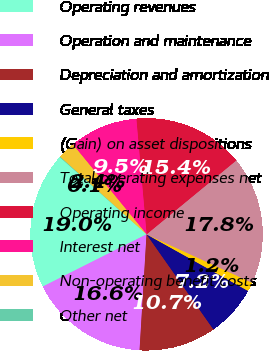Convert chart to OTSL. <chart><loc_0><loc_0><loc_500><loc_500><pie_chart><fcel>Operating revenues<fcel>Operation and maintenance<fcel>Depreciation and amortization<fcel>General taxes<fcel>(Gain) on asset dispositions<fcel>Total operating expenses net<fcel>Operating income<fcel>Interest net<fcel>Non-operating benefit costs<fcel>Other net<nl><fcel>18.99%<fcel>16.62%<fcel>10.71%<fcel>7.16%<fcel>1.25%<fcel>17.81%<fcel>15.44%<fcel>9.53%<fcel>2.43%<fcel>0.07%<nl></chart> 